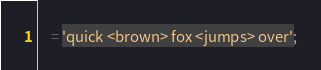Convert code to text. <code><loc_0><loc_0><loc_500><loc_500><_SQL_>    = 'quick <brown> fox <jumps> over';</code> 